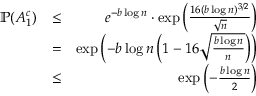Convert formula to latex. <formula><loc_0><loc_0><loc_500><loc_500>\begin{array} { r l r } { \mathbb { P } ( A _ { 1 } ^ { c } ) } & { \leq } & { e ^ { - b \log { n } } \cdot \exp \left ( \frac { 1 6 ( b \log { n } ) ^ { 3 / 2 } } { \sqrt { n } } \right ) } \\ & { = } & { \exp \left ( - b \log { n } \left ( 1 - 1 6 \sqrt { \frac { b \log { n } } { n } } \right ) \right ) } \\ & { \leq } & { \exp \left ( - \frac { b \log { n } } { 2 } \right ) } \end{array}</formula> 